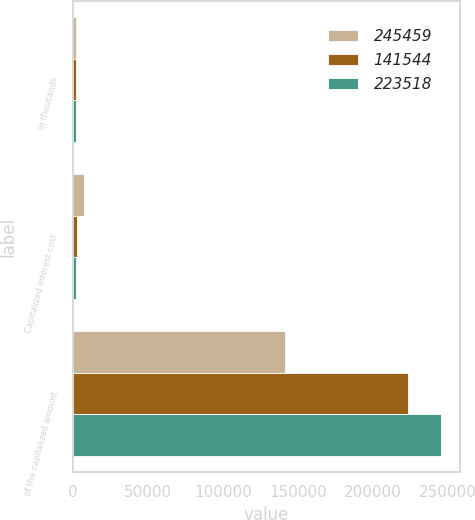<chart> <loc_0><loc_0><loc_500><loc_500><stacked_bar_chart><ecel><fcel>in thousands<fcel>Capitalized interest cost<fcel>of the capitalized amount<nl><fcel>245459<fcel>2016<fcel>7468<fcel>141544<nl><fcel>141544<fcel>2015<fcel>2930<fcel>223518<nl><fcel>223518<fcel>2014<fcel>2092<fcel>245459<nl></chart> 